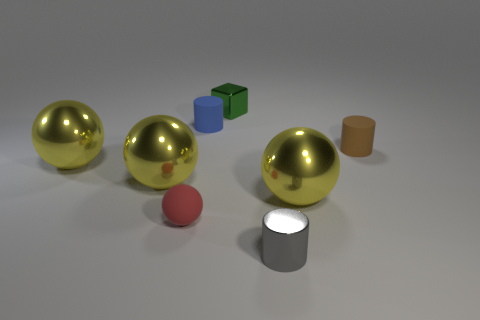Add 1 tiny things. How many objects exist? 9 Subtract all brown cylinders. How many cylinders are left? 2 Subtract all shiny cylinders. How many cylinders are left? 2 Subtract all blocks. How many objects are left? 7 Subtract 4 balls. How many balls are left? 0 Subtract all small balls. Subtract all small green objects. How many objects are left? 6 Add 5 big balls. How many big balls are left? 8 Add 1 red spheres. How many red spheres exist? 2 Subtract 0 blue blocks. How many objects are left? 8 Subtract all purple cylinders. Subtract all yellow cubes. How many cylinders are left? 3 